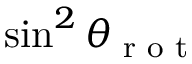<formula> <loc_0><loc_0><loc_500><loc_500>\sin ^ { 2 } \theta _ { r o t }</formula> 